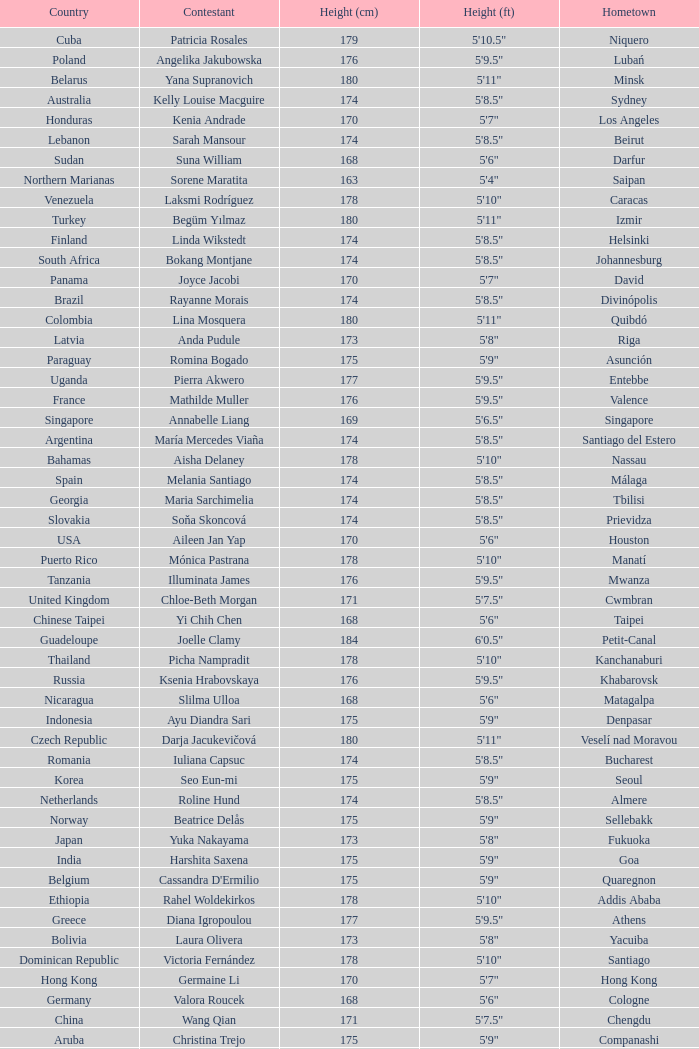What is Cynthia Mobumba's height? 5'8". Parse the full table. {'header': ['Country', 'Contestant', 'Height (cm)', 'Height (ft)', 'Hometown'], 'rows': [['Cuba', 'Patricia Rosales', '179', '5\'10.5"', 'Niquero'], ['Poland', 'Angelika Jakubowska', '176', '5\'9.5"', 'Lubań'], ['Belarus', 'Yana Supranovich', '180', '5\'11"', 'Minsk'], ['Australia', 'Kelly Louise Macguire', '174', '5\'8.5"', 'Sydney'], ['Honduras', 'Kenia Andrade', '170', '5\'7"', 'Los Angeles'], ['Lebanon', 'Sarah Mansour', '174', '5\'8.5"', 'Beirut'], ['Sudan', 'Suna William', '168', '5\'6"', 'Darfur'], ['Northern Marianas', 'Sorene Maratita', '163', '5\'4"', 'Saipan'], ['Venezuela', 'Laksmi Rodríguez', '178', '5\'10"', 'Caracas'], ['Turkey', 'Begüm Yılmaz', '180', '5\'11"', 'Izmir'], ['Finland', 'Linda Wikstedt', '174', '5\'8.5"', 'Helsinki'], ['South Africa', 'Bokang Montjane', '174', '5\'8.5"', 'Johannesburg'], ['Panama', 'Joyce Jacobi', '170', '5\'7"', 'David'], ['Brazil', 'Rayanne Morais', '174', '5\'8.5"', 'Divinópolis'], ['Colombia', 'Lina Mosquera', '180', '5\'11"', 'Quibdó'], ['Latvia', 'Anda Pudule', '173', '5\'8"', 'Riga'], ['Paraguay', 'Romina Bogado', '175', '5\'9"', 'Asunción'], ['Uganda', 'Pierra Akwero', '177', '5\'9.5"', 'Entebbe'], ['France', 'Mathilde Muller', '176', '5\'9.5"', 'Valence'], ['Singapore', 'Annabelle Liang', '169', '5\'6.5"', 'Singapore'], ['Argentina', 'María Mercedes Viaña', '174', '5\'8.5"', 'Santiago del Estero'], ['Bahamas', 'Aisha Delaney', '178', '5\'10"', 'Nassau'], ['Spain', 'Melania Santiago', '174', '5\'8.5"', 'Málaga'], ['Georgia', 'Maria Sarchimelia', '174', '5\'8.5"', 'Tbilisi'], ['Slovakia', 'Soňa Skoncová', '174', '5\'8.5"', 'Prievidza'], ['USA', 'Aileen Jan Yap', '170', '5\'6"', 'Houston'], ['Puerto Rico', 'Mónica Pastrana', '178', '5\'10"', 'Manatí'], ['Tanzania', 'Illuminata James', '176', '5\'9.5"', 'Mwanza'], ['United Kingdom', 'Chloe-Beth Morgan', '171', '5\'7.5"', 'Cwmbran'], ['Chinese Taipei', 'Yi Chih Chen', '168', '5\'6"', 'Taipei'], ['Guadeloupe', 'Joelle Clamy', '184', '6\'0.5"', 'Petit-Canal'], ['Thailand', 'Picha Nampradit', '178', '5\'10"', 'Kanchanaburi'], ['Russia', 'Ksenia Hrabovskaya', '176', '5\'9.5"', 'Khabarovsk'], ['Nicaragua', 'Slilma Ulloa', '168', '5\'6"', 'Matagalpa'], ['Indonesia', 'Ayu Diandra Sari', '175', '5\'9"', 'Denpasar'], ['Czech Republic', 'Darja Jacukevičová', '180', '5\'11"', 'Veselí nad Moravou'], ['Romania', 'Iuliana Capsuc', '174', '5\'8.5"', 'Bucharest'], ['Korea', 'Seo Eun-mi', '175', '5\'9"', 'Seoul'], ['Netherlands', 'Roline Hund', '174', '5\'8.5"', 'Almere'], ['Norway', 'Beatrice Delås', '175', '5\'9"', 'Sellebakk'], ['Japan', 'Yuka Nakayama', '173', '5\'8"', 'Fukuoka'], ['India', 'Harshita Saxena', '175', '5\'9"', 'Goa'], ['Belgium', "Cassandra D'Ermilio", '175', '5\'9"', 'Quaregnon'], ['Ethiopia', 'Rahel Woldekirkos', '178', '5\'10"', 'Addis Ababa'], ['Greece', 'Diana Igropoulou', '177', '5\'9.5"', 'Athens'], ['Bolivia', 'Laura Olivera', '173', '5\'8"', 'Yacuiba'], ['Dominican Republic', 'Victoria Fernández', '178', '5\'10"', 'Santiago'], ['Hong Kong', 'Germaine Li', '170', '5\'7"', 'Hong Kong'], ['Germany', 'Valora Roucek', '168', '5\'6"', 'Cologne'], ['China', 'Wang Qian', '171', '5\'7.5"', 'Chengdu'], ['Aruba', 'Christina Trejo', '175', '5\'9"', 'Companashi'], ['Kyrgyzstan', 'Altynai Ismankulova', '170', '5\'7"', 'Bishkek'], ['Macau', 'Yvonne Yang', '179', '5\'10.5"', 'Macau'], ['El Salvador', 'Vanessa Hueck', '178', '5\'10"', 'San Salvador'], ['Canada', 'Chanel Beckenlehner', '173', '5\'8"', 'Toronto'], ['Mongolia', 'Badamgerel Khurelbaatar', '178', '5\'10"', 'Ulaan Baatar'], ['Peru', 'Alejandra Pezet', '176', '5\'9.5"', 'Lima'], ['Martinique', 'Nathaly Peters', '175', '5\'9"', 'Fort de France'], ['Ecuador', 'Isabella Chiriboga', '174', '5\'8.5"', 'Quito'], ['Gabon', 'Cynthia Mobumba', '172', '5\'8"', 'Ngounié'], ['Philippines', 'Melody Gersbach †', '175', '5\'7"', 'Daraga'], ['Moldova', 'Catalina Stascu', '173', '5\'8"', 'Chişinău'], ['Malaysia', 'Tay Tze Juan', '173', '5\'8"', 'Batu Pahat'], ['Mexico', 'Anagabriela Espinoza', '180', '5\'11"', 'Monterrey'], ['Vietnam', 'Trần Thị Quỳnh', '175', '5\'9"', 'Hai Phong']]} 